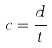Convert formula to latex. <formula><loc_0><loc_0><loc_500><loc_500>c = \frac { d } { t }</formula> 